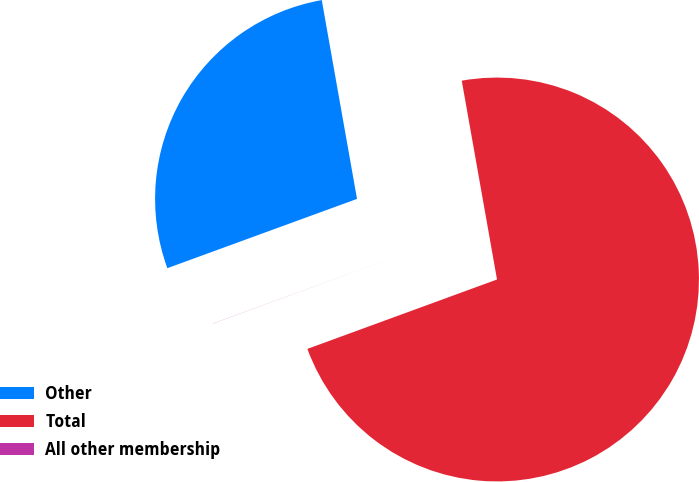Convert chart to OTSL. <chart><loc_0><loc_0><loc_500><loc_500><pie_chart><fcel>Other<fcel>Total<fcel>All other membership<nl><fcel>27.78%<fcel>72.21%<fcel>0.01%<nl></chart> 